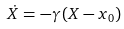Convert formula to latex. <formula><loc_0><loc_0><loc_500><loc_500>\dot { X } = - \gamma \, ( X - x _ { 0 } )</formula> 